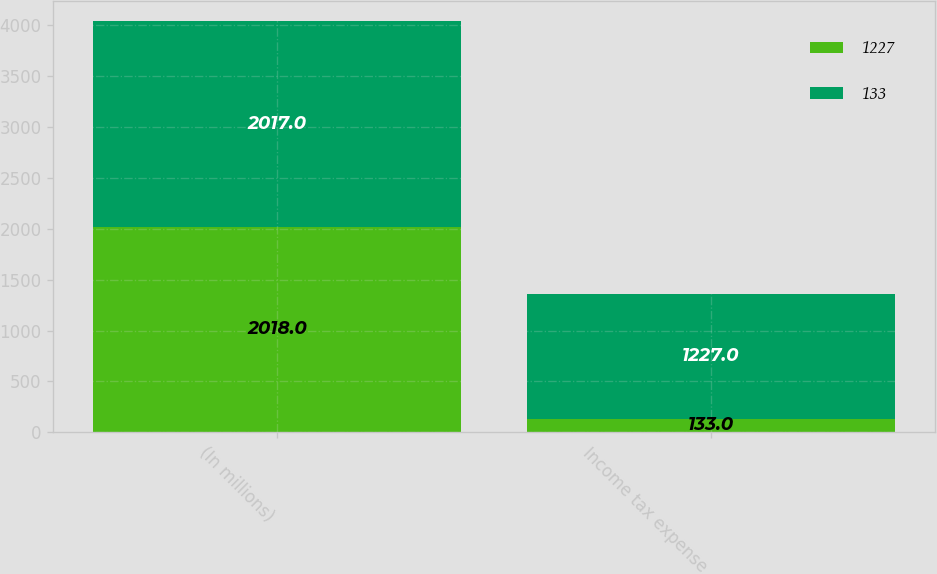<chart> <loc_0><loc_0><loc_500><loc_500><stacked_bar_chart><ecel><fcel>(In millions)<fcel>Income tax expense<nl><fcel>1227<fcel>2018<fcel>133<nl><fcel>133<fcel>2017<fcel>1227<nl></chart> 